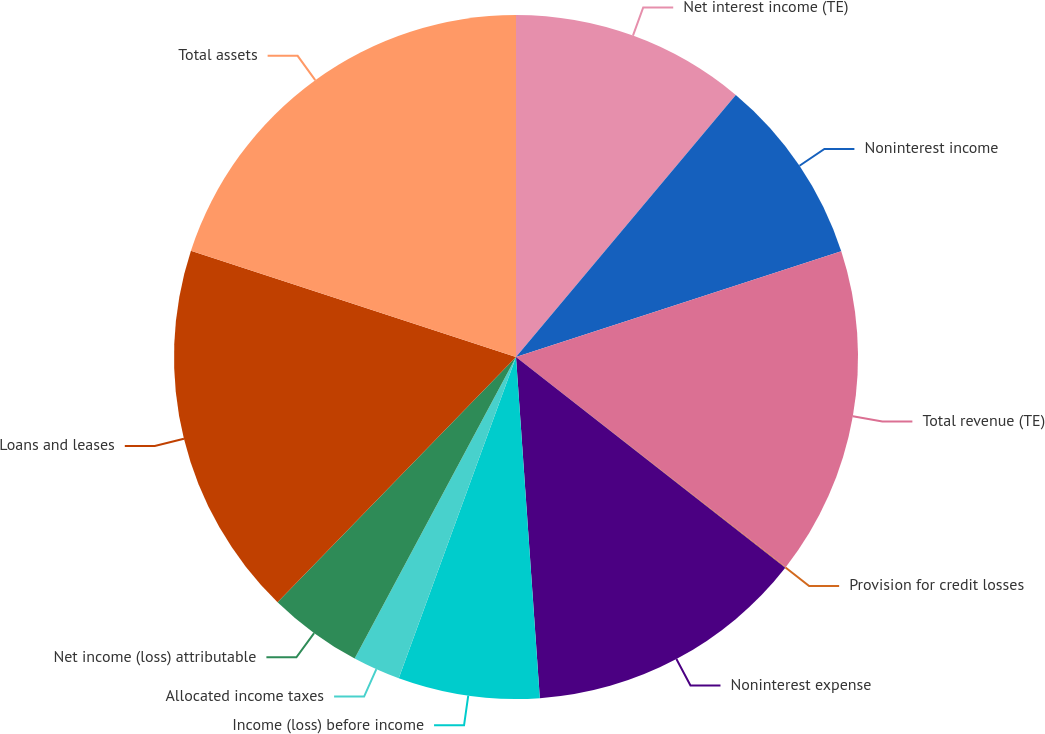Convert chart to OTSL. <chart><loc_0><loc_0><loc_500><loc_500><pie_chart><fcel>Net interest income (TE)<fcel>Noninterest income<fcel>Total revenue (TE)<fcel>Provision for credit losses<fcel>Noninterest expense<fcel>Income (loss) before income<fcel>Allocated income taxes<fcel>Net income (loss) attributable<fcel>Loans and leases<fcel>Total assets<nl><fcel>11.11%<fcel>8.89%<fcel>15.54%<fcel>0.03%<fcel>13.32%<fcel>6.68%<fcel>2.25%<fcel>4.46%<fcel>17.75%<fcel>19.97%<nl></chart> 